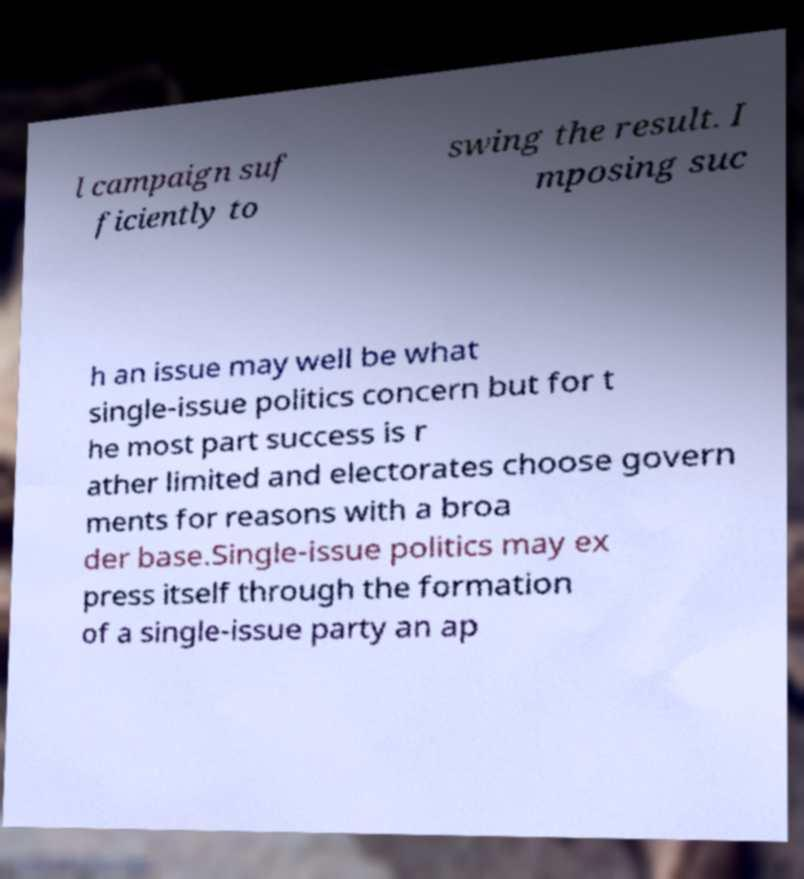Can you read and provide the text displayed in the image?This photo seems to have some interesting text. Can you extract and type it out for me? l campaign suf ficiently to swing the result. I mposing suc h an issue may well be what single-issue politics concern but for t he most part success is r ather limited and electorates choose govern ments for reasons with a broa der base.Single-issue politics may ex press itself through the formation of a single-issue party an ap 